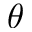Convert formula to latex. <formula><loc_0><loc_0><loc_500><loc_500>\theta</formula> 